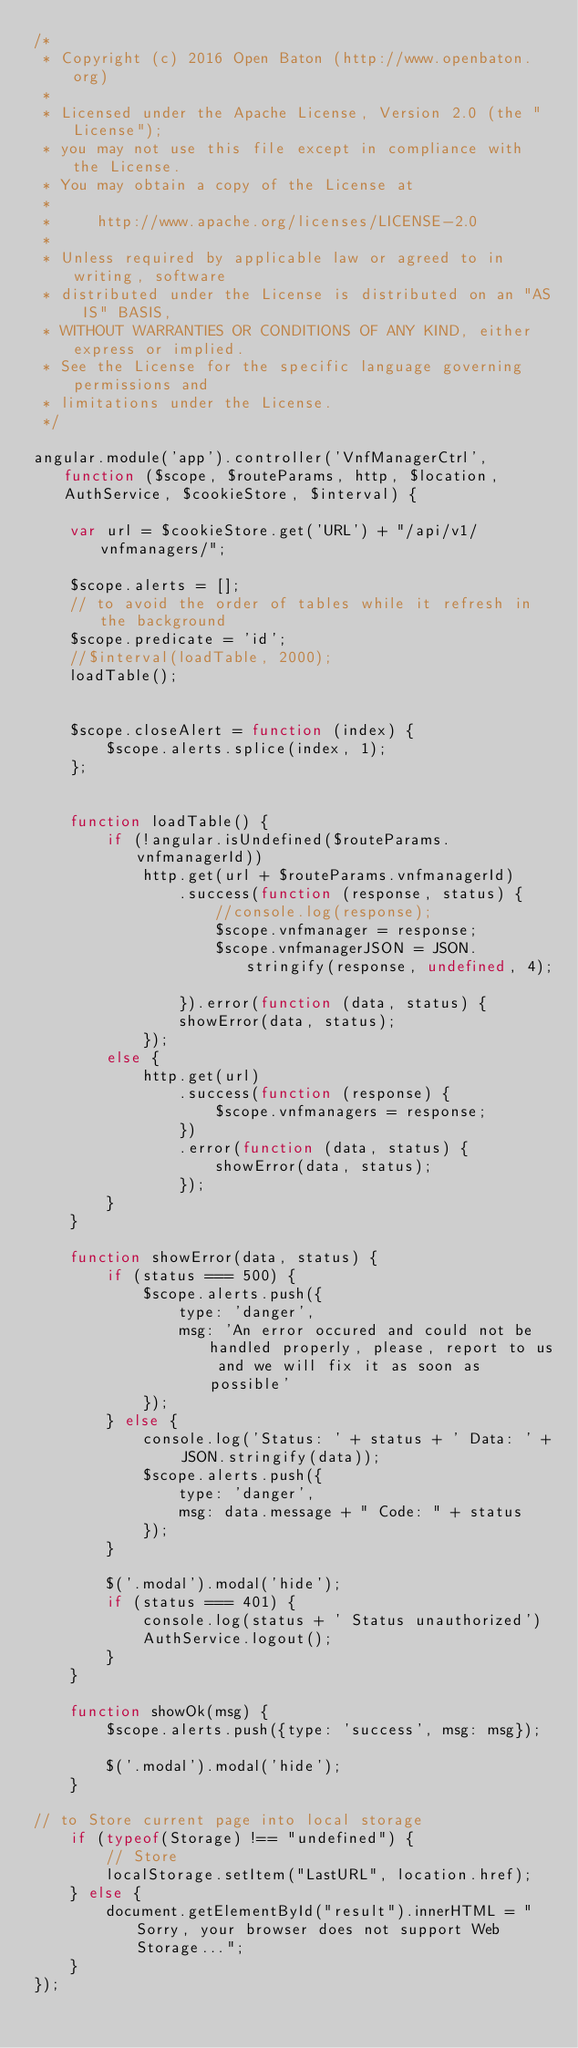<code> <loc_0><loc_0><loc_500><loc_500><_JavaScript_>/*
 * Copyright (c) 2016 Open Baton (http://www.openbaton.org)
 *
 * Licensed under the Apache License, Version 2.0 (the "License");
 * you may not use this file except in compliance with the License.
 * You may obtain a copy of the License at
 *
 *     http://www.apache.org/licenses/LICENSE-2.0
 *
 * Unless required by applicable law or agreed to in writing, software
 * distributed under the License is distributed on an "AS IS" BASIS,
 * WITHOUT WARRANTIES OR CONDITIONS OF ANY KIND, either express or implied.
 * See the License for the specific language governing permissions and
 * limitations under the License.
 */

angular.module('app').controller('VnfManagerCtrl', function ($scope, $routeParams, http, $location, AuthService, $cookieStore, $interval) {

    var url = $cookieStore.get('URL') + "/api/v1/vnfmanagers/";

    $scope.alerts = [];
    // to avoid the order of tables while it refresh in the background
    $scope.predicate = 'id';
    //$interval(loadTable, 2000);
    loadTable();


    $scope.closeAlert = function (index) {
        $scope.alerts.splice(index, 1);
    };


    function loadTable() {
        if (!angular.isUndefined($routeParams.vnfmanagerId))
            http.get(url + $routeParams.vnfmanagerId)
                .success(function (response, status) {
                    //console.log(response);
                    $scope.vnfmanager = response;
                    $scope.vnfmanagerJSON = JSON.stringify(response, undefined, 4);

                }).error(function (data, status) {
                showError(data, status);
            });
        else {
            http.get(url)
                .success(function (response) {
                    $scope.vnfmanagers = response;
                })
                .error(function (data, status) {
                    showError(data, status);
                });
        }
    }

    function showError(data, status) {
        if (status === 500) {
            $scope.alerts.push({
                type: 'danger',
                msg: 'An error occured and could not be handled properly, please, report to us and we will fix it as soon as possible'
            });
        } else {
            console.log('Status: ' + status + ' Data: ' + JSON.stringify(data));
            $scope.alerts.push({
                type: 'danger',
                msg: data.message + " Code: " + status
            });
        }

        $('.modal').modal('hide');
        if (status === 401) {
            console.log(status + ' Status unauthorized')
            AuthService.logout();
        }
    }

    function showOk(msg) {
        $scope.alerts.push({type: 'success', msg: msg});

        $('.modal').modal('hide');
    }

// to Store current page into local storage
    if (typeof(Storage) !== "undefined") {
        // Store
        localStorage.setItem("LastURL", location.href);
    } else {
        document.getElementById("result").innerHTML = "Sorry, your browser does not support Web Storage...";
    }
});
</code> 